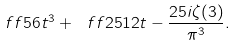Convert formula to latex. <formula><loc_0><loc_0><loc_500><loc_500>\ f f 5 6 t ^ { 3 } + \ f f { 2 5 } { 1 2 } t - \frac { 2 5 i \zeta ( 3 ) } { \pi ^ { 3 } } .</formula> 